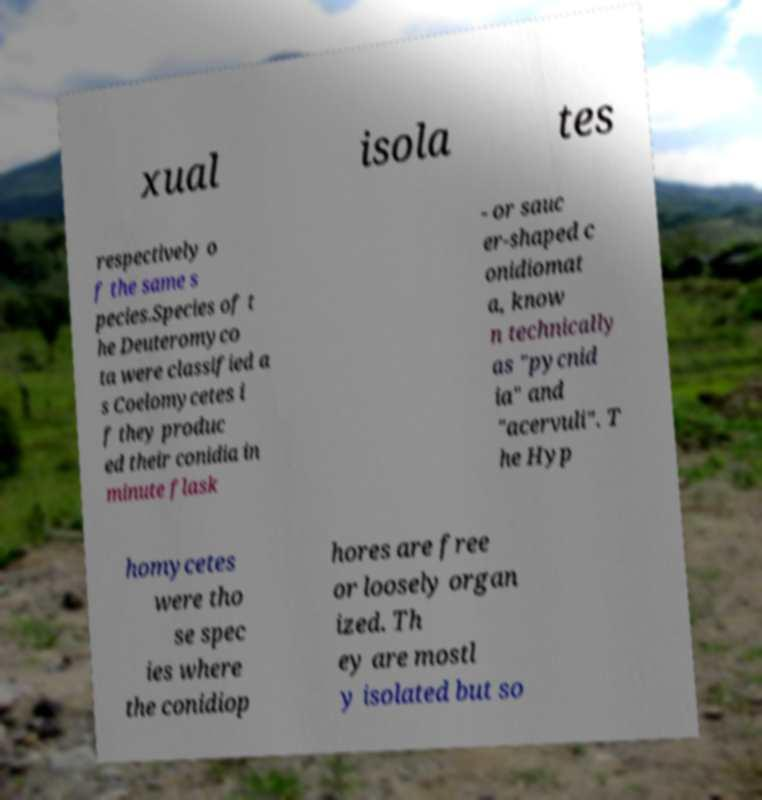Could you extract and type out the text from this image? xual isola tes respectively o f the same s pecies.Species of t he Deuteromyco ta were classified a s Coelomycetes i f they produc ed their conidia in minute flask - or sauc er-shaped c onidiomat a, know n technically as "pycnid ia" and "acervuli". T he Hyp homycetes were tho se spec ies where the conidiop hores are free or loosely organ ized. Th ey are mostl y isolated but so 